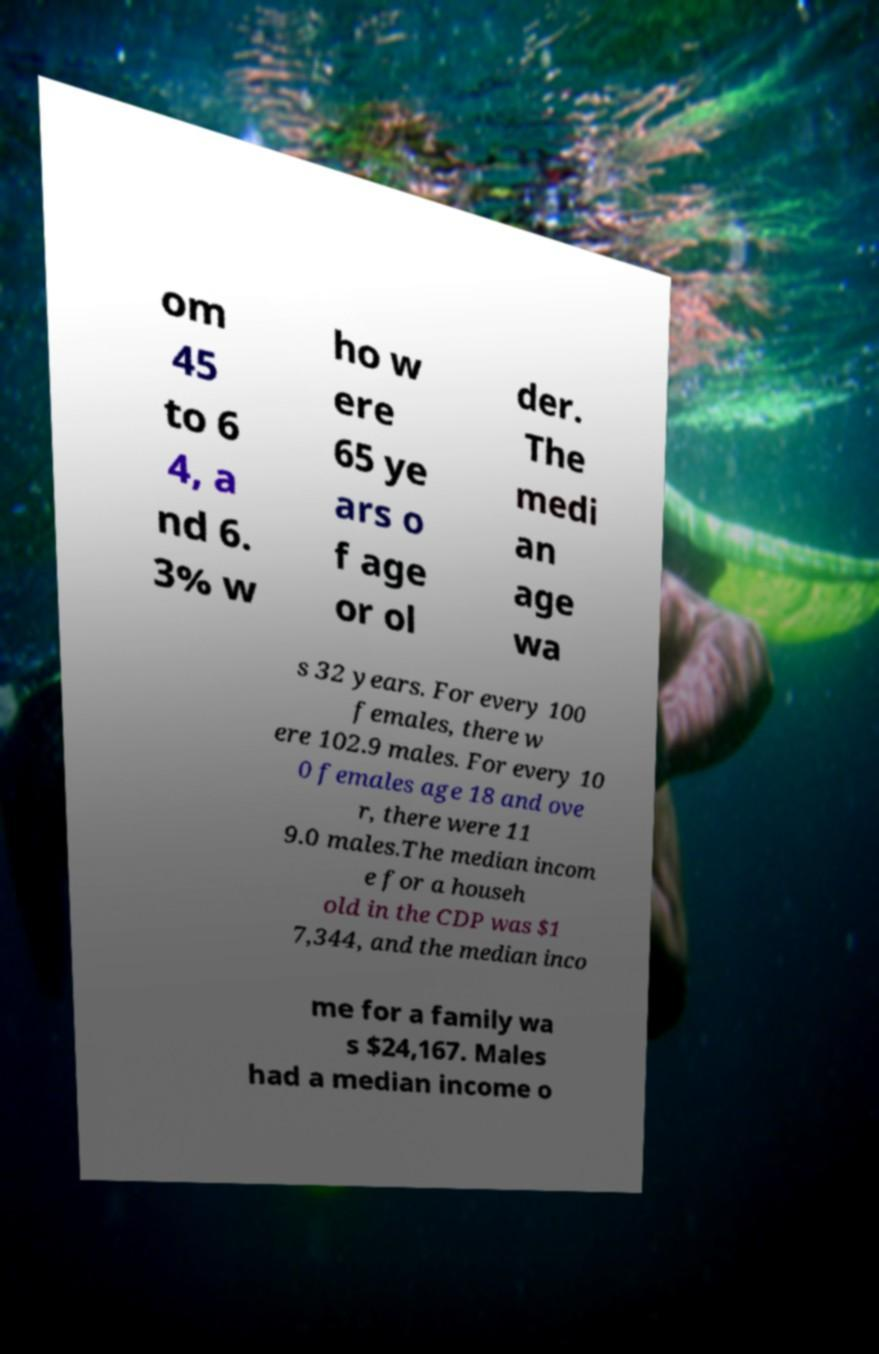Please identify and transcribe the text found in this image. om 45 to 6 4, a nd 6. 3% w ho w ere 65 ye ars o f age or ol der. The medi an age wa s 32 years. For every 100 females, there w ere 102.9 males. For every 10 0 females age 18 and ove r, there were 11 9.0 males.The median incom e for a househ old in the CDP was $1 7,344, and the median inco me for a family wa s $24,167. Males had a median income o 